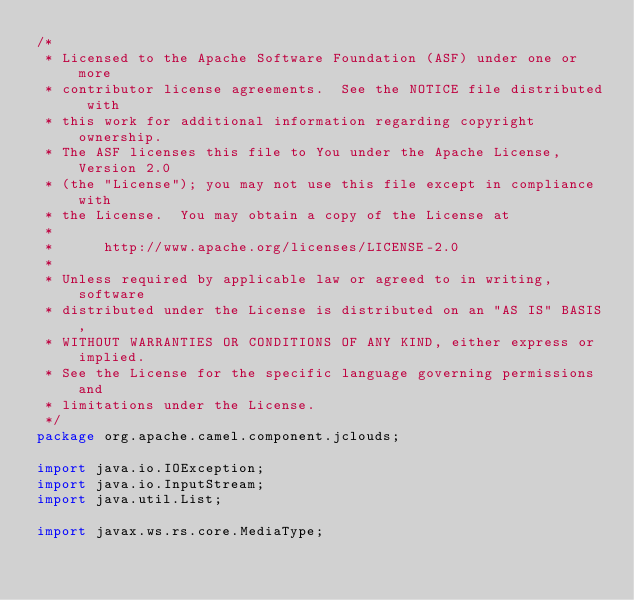Convert code to text. <code><loc_0><loc_0><loc_500><loc_500><_Java_>/*
 * Licensed to the Apache Software Foundation (ASF) under one or more
 * contributor license agreements.  See the NOTICE file distributed with
 * this work for additional information regarding copyright ownership.
 * The ASF licenses this file to You under the Apache License, Version 2.0
 * (the "License"); you may not use this file except in compliance with
 * the License.  You may obtain a copy of the License at
 *
 *      http://www.apache.org/licenses/LICENSE-2.0
 *
 * Unless required by applicable law or agreed to in writing, software
 * distributed under the License is distributed on an "AS IS" BASIS,
 * WITHOUT WARRANTIES OR CONDITIONS OF ANY KIND, either express or implied.
 * See the License for the specific language governing permissions and
 * limitations under the License.
 */
package org.apache.camel.component.jclouds;

import java.io.IOException;
import java.io.InputStream;
import java.util.List;

import javax.ws.rs.core.MediaType;
</code> 